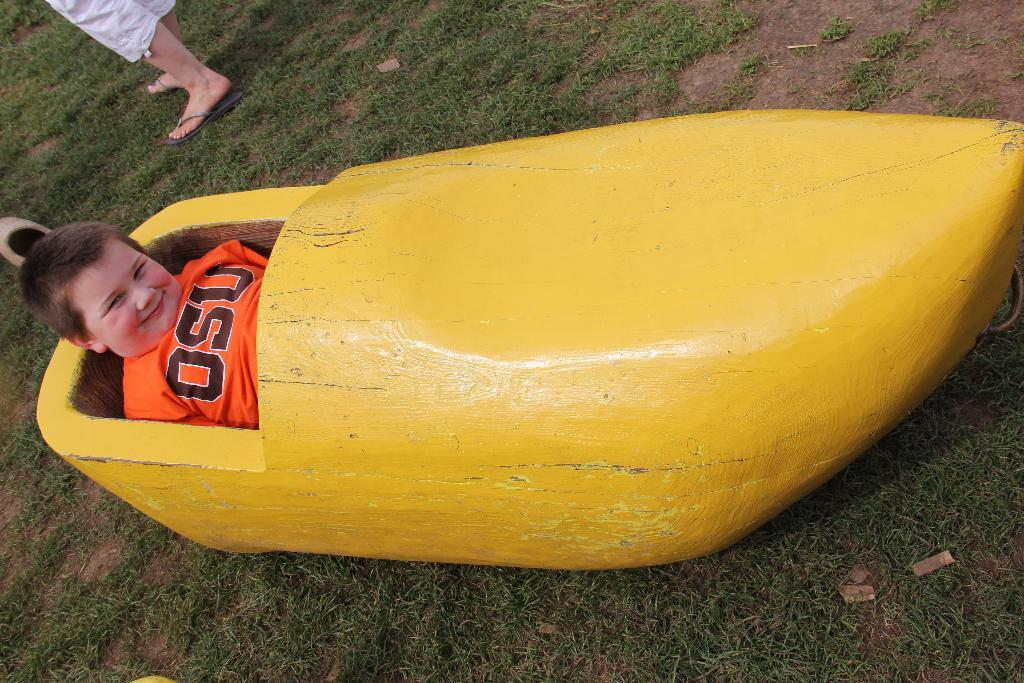<image>
Give a short and clear explanation of the subsequent image. a boy wearing an orage OSU t shirt laying in a yellow boat 